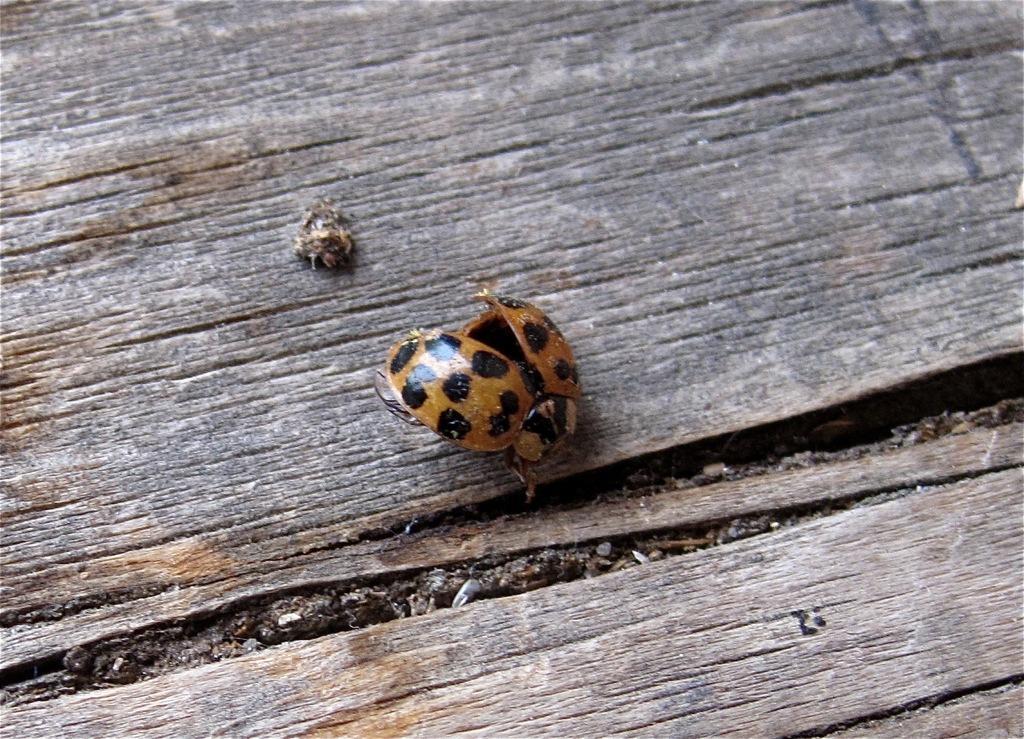Please provide a concise description of this image. As we can see in the image there are insects on wooden surface. 